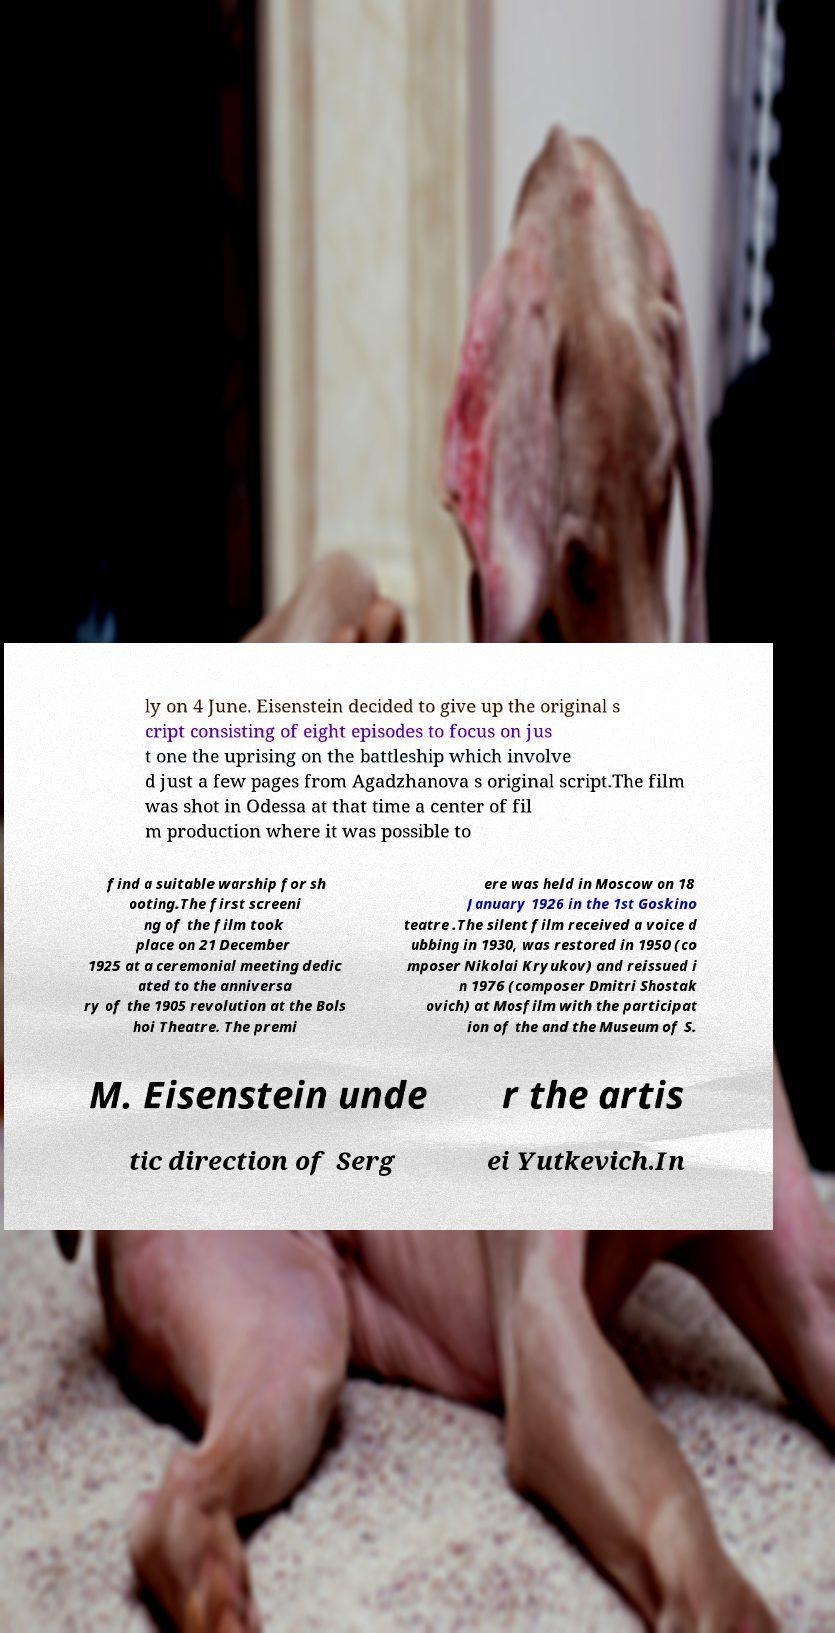Can you read and provide the text displayed in the image?This photo seems to have some interesting text. Can you extract and type it out for me? ly on 4 June. Eisenstein decided to give up the original s cript consisting of eight episodes to focus on jus t one the uprising on the battleship which involve d just a few pages from Agadzhanova s original script.The film was shot in Odessa at that time a center of fil m production where it was possible to find a suitable warship for sh ooting.The first screeni ng of the film took place on 21 December 1925 at a ceremonial meeting dedic ated to the anniversa ry of the 1905 revolution at the Bols hoi Theatre. The premi ere was held in Moscow on 18 January 1926 in the 1st Goskino teatre .The silent film received a voice d ubbing in 1930, was restored in 1950 (co mposer Nikolai Kryukov) and reissued i n 1976 (composer Dmitri Shostak ovich) at Mosfilm with the participat ion of the and the Museum of S. M. Eisenstein unde r the artis tic direction of Serg ei Yutkevich.In 